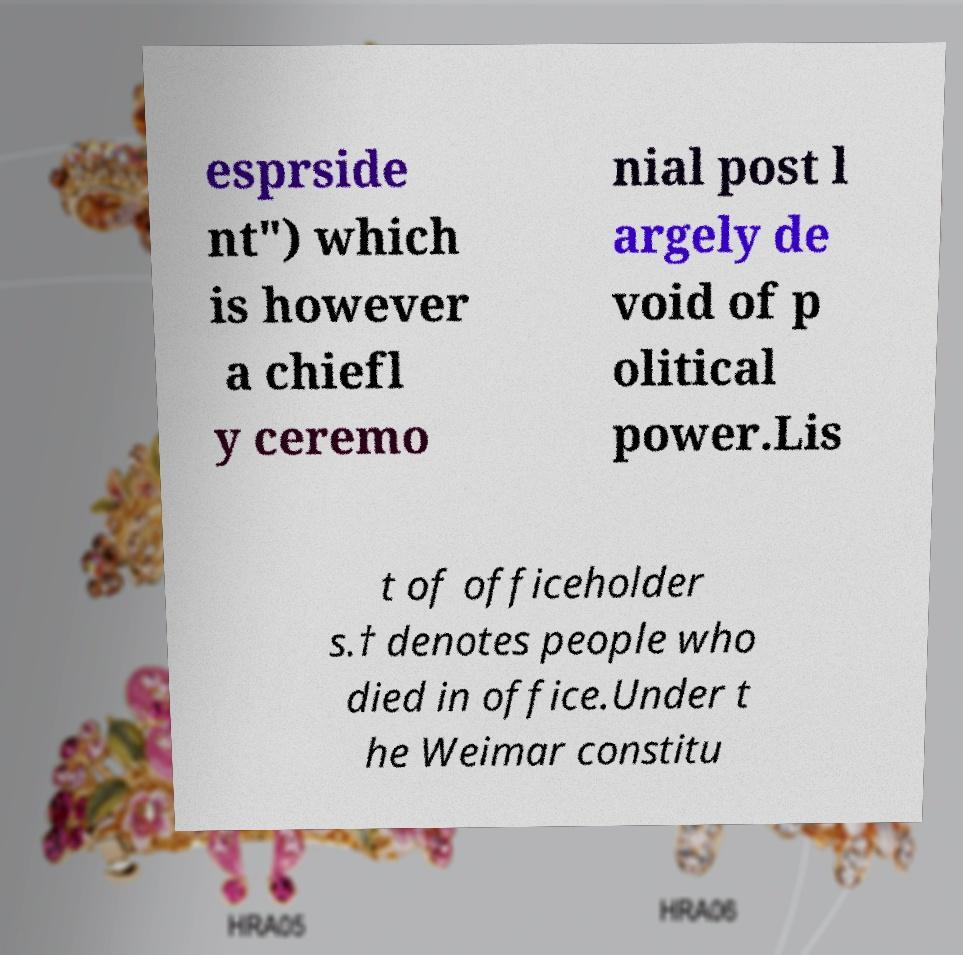I need the written content from this picture converted into text. Can you do that? esprside nt") which is however a chiefl y ceremo nial post l argely de void of p olitical power.Lis t of officeholder s.† denotes people who died in office.Under t he Weimar constitu 